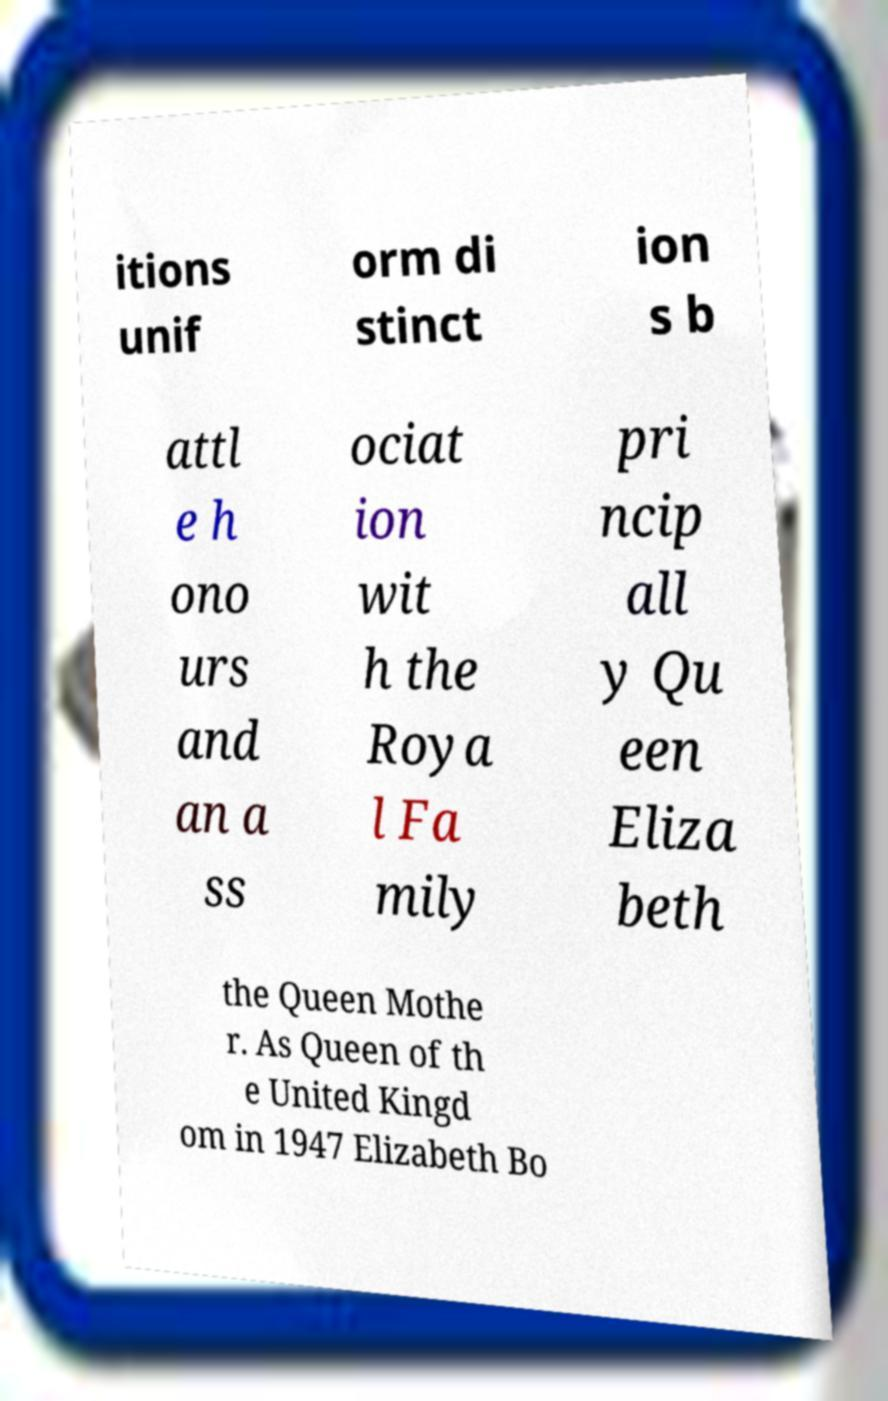Please identify and transcribe the text found in this image. itions unif orm di stinct ion s b attl e h ono urs and an a ss ociat ion wit h the Roya l Fa mily pri ncip all y Qu een Eliza beth the Queen Mothe r. As Queen of th e United Kingd om in 1947 Elizabeth Bo 